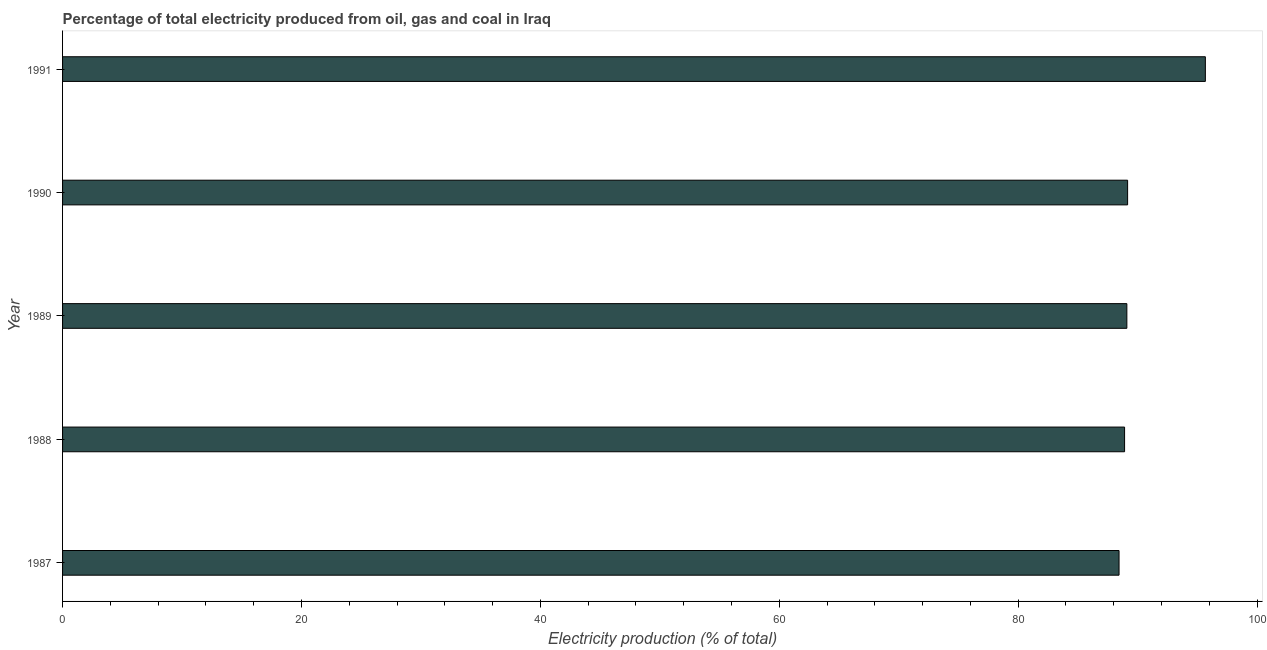Does the graph contain grids?
Ensure brevity in your answer.  No. What is the title of the graph?
Give a very brief answer. Percentage of total electricity produced from oil, gas and coal in Iraq. What is the label or title of the X-axis?
Provide a succinct answer. Electricity production (% of total). What is the electricity production in 1988?
Make the answer very short. 88.91. Across all years, what is the maximum electricity production?
Your response must be concise. 95.68. Across all years, what is the minimum electricity production?
Your answer should be very brief. 88.45. In which year was the electricity production minimum?
Your answer should be very brief. 1987. What is the sum of the electricity production?
Provide a succinct answer. 451.31. What is the difference between the electricity production in 1988 and 1990?
Your answer should be compact. -0.25. What is the average electricity production per year?
Provide a short and direct response. 90.26. What is the median electricity production?
Provide a succinct answer. 89.1. What is the difference between the highest and the second highest electricity production?
Your response must be concise. 6.51. Is the sum of the electricity production in 1989 and 1991 greater than the maximum electricity production across all years?
Your response must be concise. Yes. What is the difference between the highest and the lowest electricity production?
Provide a succinct answer. 7.23. How many years are there in the graph?
Keep it short and to the point. 5. Are the values on the major ticks of X-axis written in scientific E-notation?
Provide a short and direct response. No. What is the Electricity production (% of total) of 1987?
Provide a succinct answer. 88.45. What is the Electricity production (% of total) in 1988?
Offer a very short reply. 88.91. What is the Electricity production (% of total) in 1989?
Ensure brevity in your answer.  89.1. What is the Electricity production (% of total) of 1990?
Offer a terse response. 89.17. What is the Electricity production (% of total) in 1991?
Make the answer very short. 95.68. What is the difference between the Electricity production (% of total) in 1987 and 1988?
Your response must be concise. -0.46. What is the difference between the Electricity production (% of total) in 1987 and 1989?
Your response must be concise. -0.65. What is the difference between the Electricity production (% of total) in 1987 and 1990?
Keep it short and to the point. -0.72. What is the difference between the Electricity production (% of total) in 1987 and 1991?
Your answer should be very brief. -7.23. What is the difference between the Electricity production (% of total) in 1988 and 1989?
Offer a terse response. -0.19. What is the difference between the Electricity production (% of total) in 1988 and 1990?
Your response must be concise. -0.25. What is the difference between the Electricity production (% of total) in 1988 and 1991?
Offer a very short reply. -6.76. What is the difference between the Electricity production (% of total) in 1989 and 1990?
Ensure brevity in your answer.  -0.06. What is the difference between the Electricity production (% of total) in 1989 and 1991?
Your response must be concise. -6.57. What is the difference between the Electricity production (% of total) in 1990 and 1991?
Offer a very short reply. -6.51. What is the ratio of the Electricity production (% of total) in 1987 to that in 1989?
Provide a short and direct response. 0.99. What is the ratio of the Electricity production (% of total) in 1987 to that in 1990?
Make the answer very short. 0.99. What is the ratio of the Electricity production (% of total) in 1987 to that in 1991?
Offer a terse response. 0.92. What is the ratio of the Electricity production (% of total) in 1988 to that in 1989?
Provide a short and direct response. 1. What is the ratio of the Electricity production (% of total) in 1988 to that in 1990?
Your response must be concise. 1. What is the ratio of the Electricity production (% of total) in 1988 to that in 1991?
Make the answer very short. 0.93. What is the ratio of the Electricity production (% of total) in 1989 to that in 1990?
Provide a succinct answer. 1. What is the ratio of the Electricity production (% of total) in 1990 to that in 1991?
Your answer should be very brief. 0.93. 